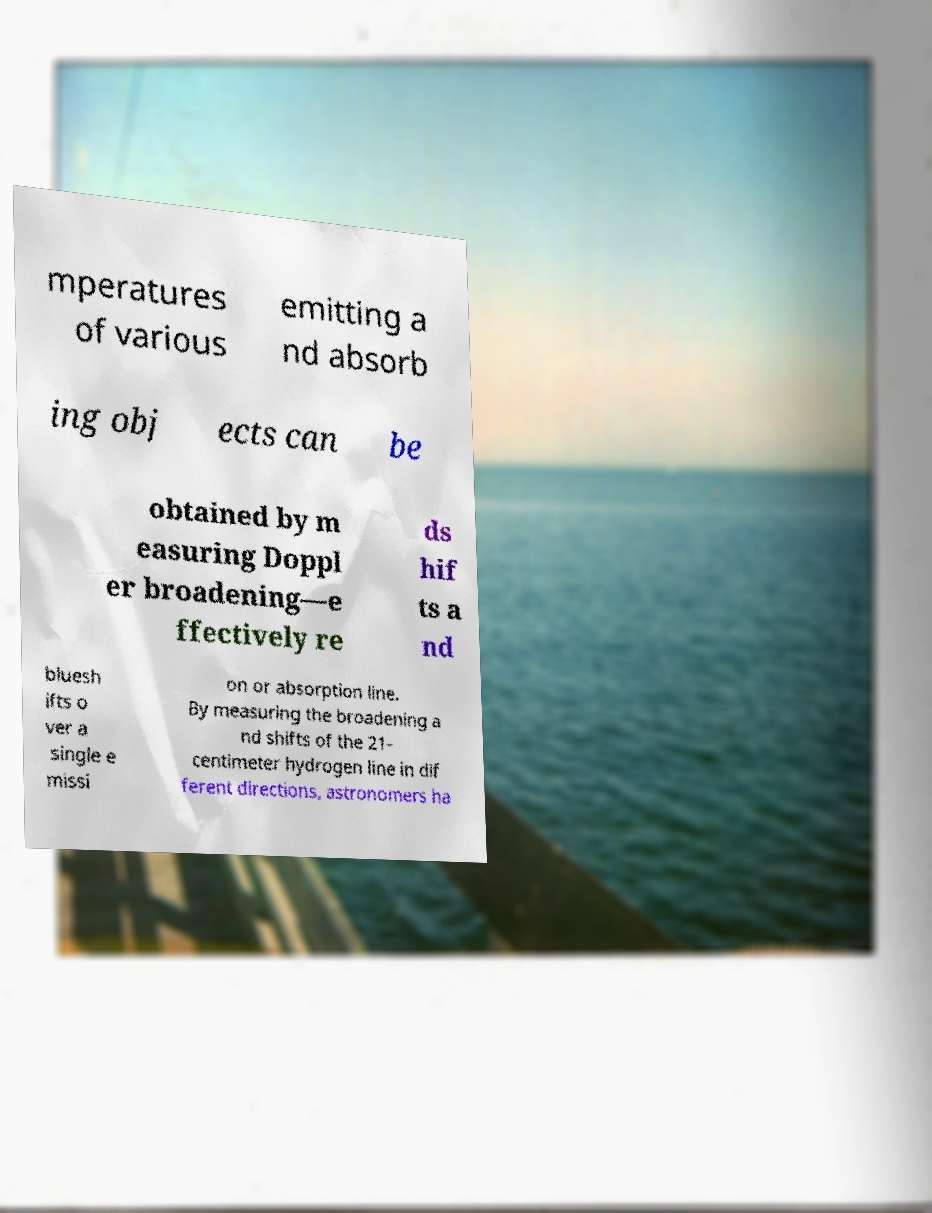Please read and relay the text visible in this image. What does it say? mperatures of various emitting a nd absorb ing obj ects can be obtained by m easuring Doppl er broadening—e ffectively re ds hif ts a nd bluesh ifts o ver a single e missi on or absorption line. By measuring the broadening a nd shifts of the 21- centimeter hydrogen line in dif ferent directions, astronomers ha 